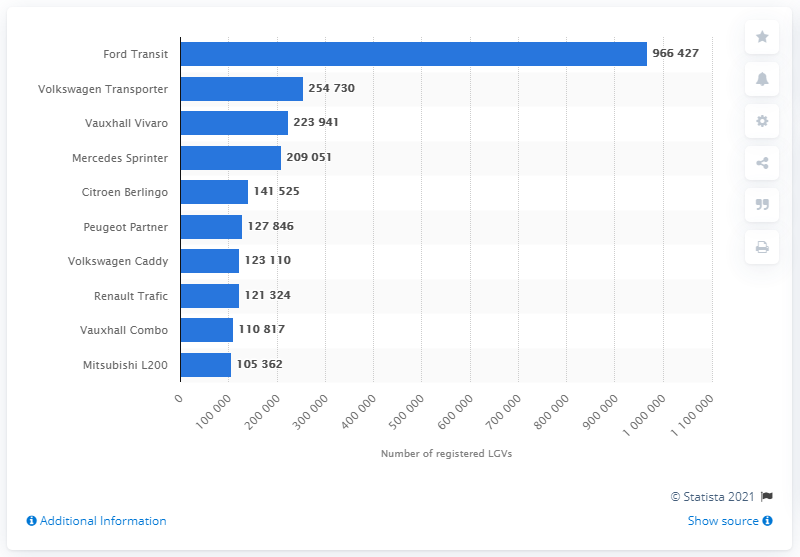Identify some key points in this picture. According to data from 2019, the Volkswagen Transporter was the leading light goods vehicle model in Great Britain. 